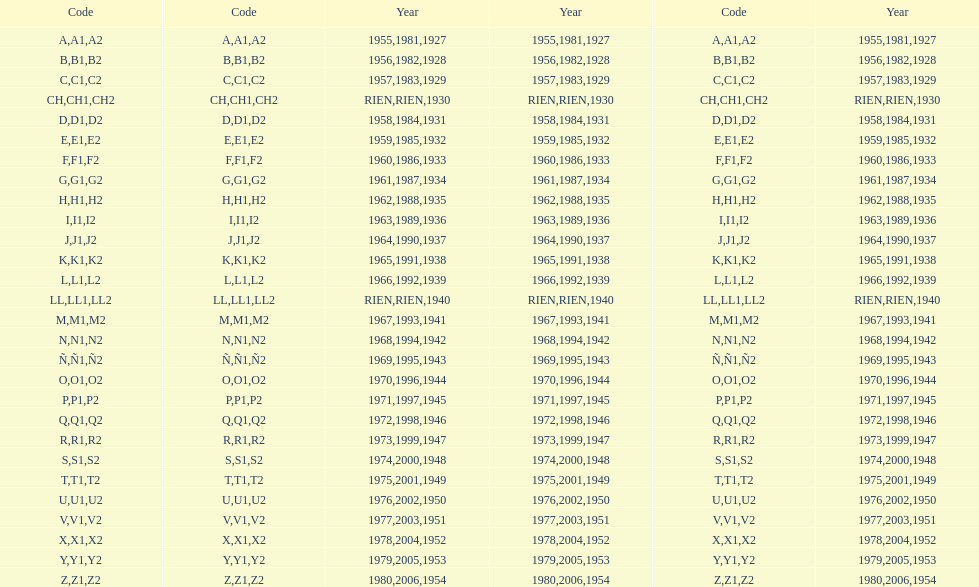What was the only year to use the code ch? 1930. 